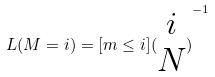<formula> <loc_0><loc_0><loc_500><loc_500>L ( M = i ) = [ m \leq i ] { ( \begin{matrix} i \\ N \end{matrix} ) } ^ { - 1 }</formula> 